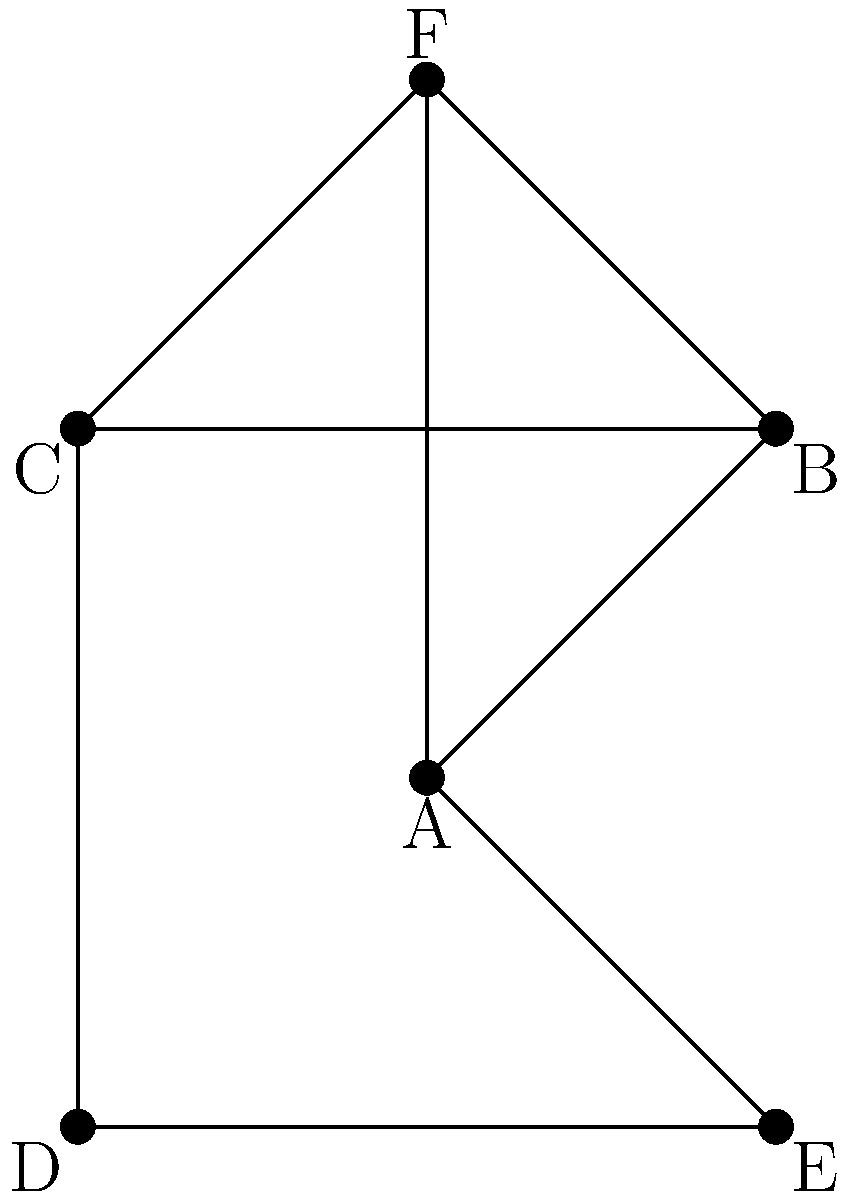In a small town, six churches (A, B, C, D, E, and F) form a religious network. The diagram shows the connections between these churches, where each line represents a shared ministry or collaborative effort. What is the minimum number of connections that need to be removed to isolate church F from the rest of the network? To solve this problem, we need to analyze the connectivity of church F to the rest of the network. Let's approach this step-by-step:

1. First, we identify all the connections that church F has:
   - F is connected to A
   - F is connected to B
   - F is connected to C

2. We need to determine the minimum number of these connections that, if removed, would completely separate F from the rest of the network.

3. In this case, F has three direct connections (to A, B, and C). If we remove all three of these connections, F will be isolated from the rest of the network.

4. There is no way to isolate F by removing fewer than three connections because:
   - If we remove only two connections, F would still have one connection to the main network.
   - The connections between the other churches (A, B, C, D, and E) don't affect F's connectivity to the network.

5. Therefore, the minimum number of connections that need to be removed to isolate church F is 3.

This problem illustrates the concept of vertex connectivity in graph theory, which is particularly relevant to understanding the resilience and structure of social or organizational networks.
Answer: 3 